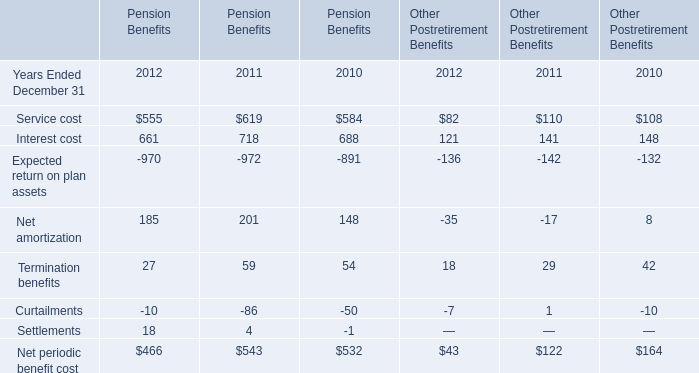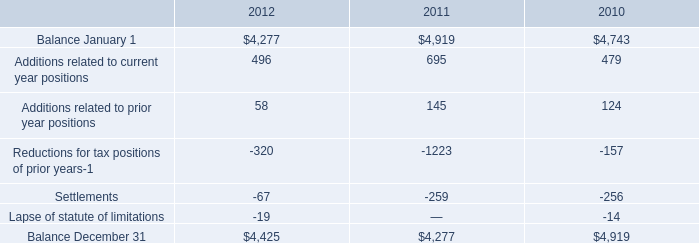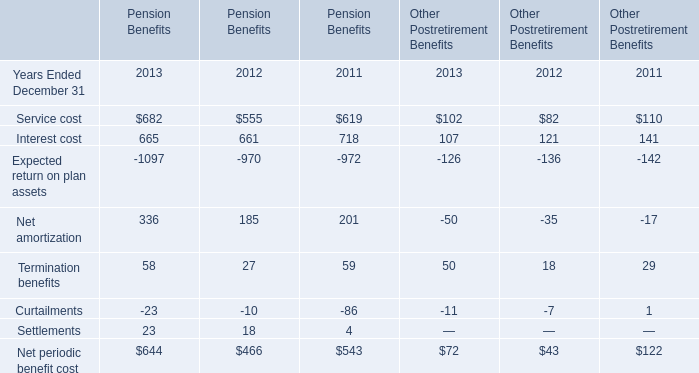In the year with largest amount of Interest cost for Pension Benefits, what's the sum of the Expected return on plan assets for Other Postretirement Benefits? 
Answer: -142.0. What is the sum of the Net amortization in the years where Service cost greater than 0 ? 
Computations: (((((336 + 185) + 201) - 50) - 35) - 17)
Answer: 620.0. Which year is Interest cost for Pension Benefits the highest? 
Answer: 2011. 